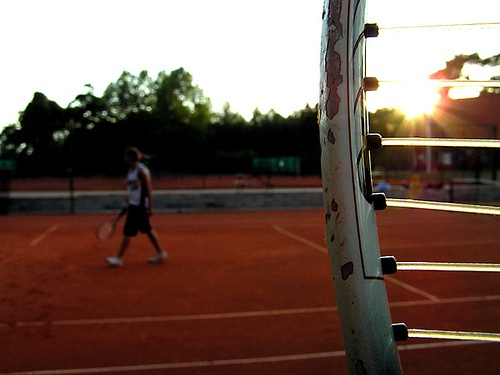Describe the objects in this image and their specific colors. I can see people in white, black, maroon, and gray tones, tennis racket in white, maroon, black, and brown tones, and people in maroon, black, and white tones in this image. 